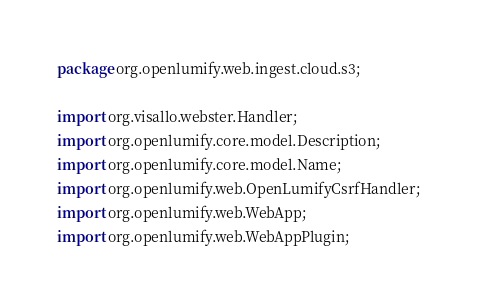<code> <loc_0><loc_0><loc_500><loc_500><_Java_>package org.openlumify.web.ingest.cloud.s3;

import org.visallo.webster.Handler;
import org.openlumify.core.model.Description;
import org.openlumify.core.model.Name;
import org.openlumify.web.OpenLumifyCsrfHandler;
import org.openlumify.web.WebApp;
import org.openlumify.web.WebAppPlugin;</code> 